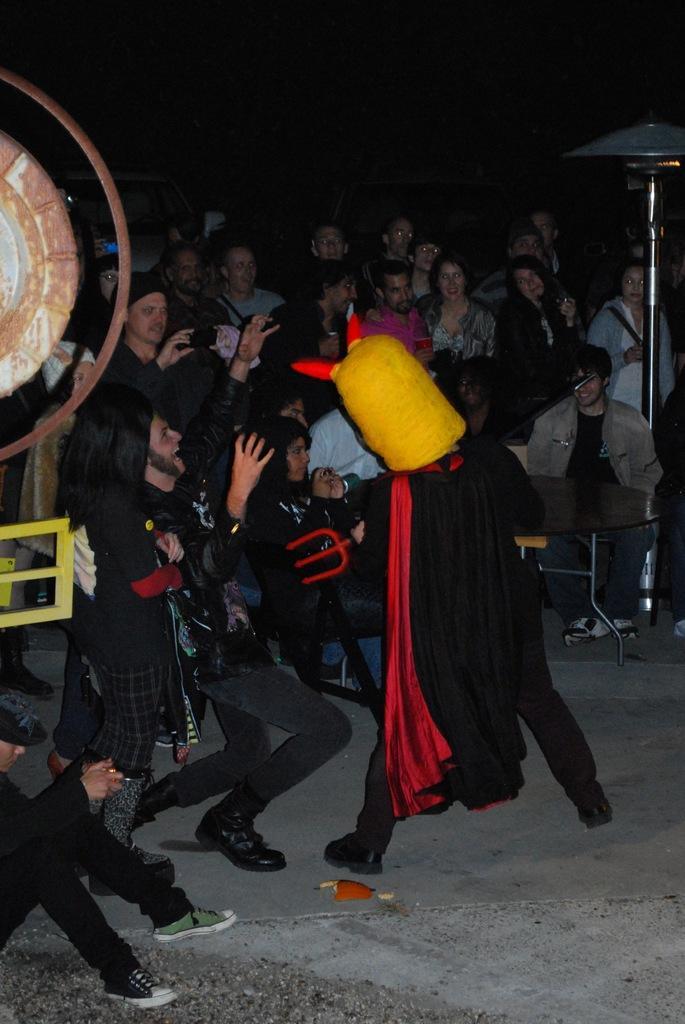In one or two sentences, can you explain what this image depicts? In this image I can see a person standing, wearing a mask and a black dress. Other people are present and there is a table and a stand at the back. 